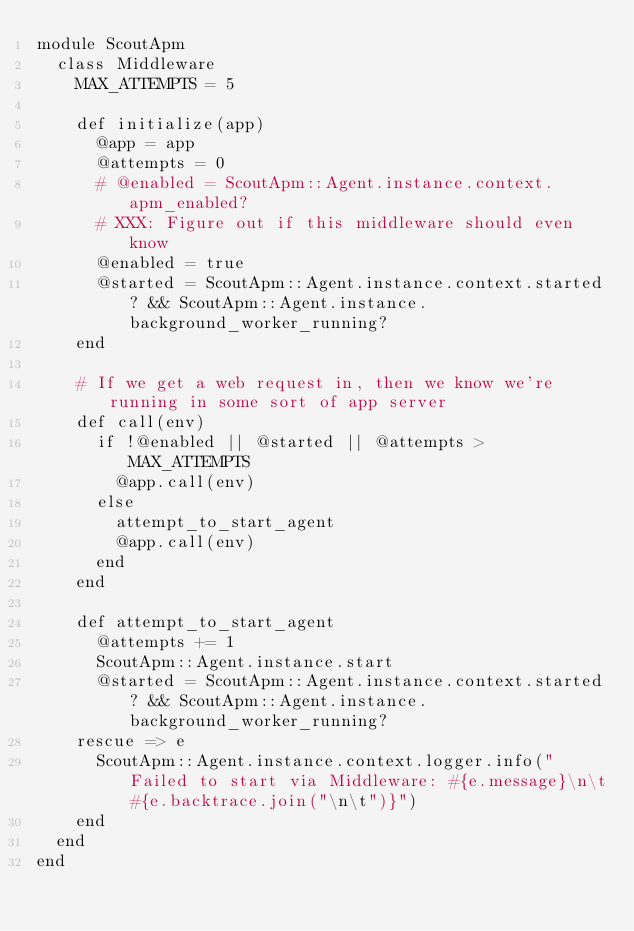<code> <loc_0><loc_0><loc_500><loc_500><_Ruby_>module ScoutApm
  class Middleware
    MAX_ATTEMPTS = 5

    def initialize(app)
      @app = app
      @attempts = 0
      # @enabled = ScoutApm::Agent.instance.context.apm_enabled?
      # XXX: Figure out if this middleware should even know
      @enabled = true
      @started = ScoutApm::Agent.instance.context.started? && ScoutApm::Agent.instance.background_worker_running?
    end

    # If we get a web request in, then we know we're running in some sort of app server
    def call(env)
      if !@enabled || @started || @attempts > MAX_ATTEMPTS
        @app.call(env)
      else
        attempt_to_start_agent
        @app.call(env)
      end
    end

    def attempt_to_start_agent
      @attempts += 1
      ScoutApm::Agent.instance.start
      @started = ScoutApm::Agent.instance.context.started? && ScoutApm::Agent.instance.background_worker_running?
    rescue => e
      ScoutApm::Agent.instance.context.logger.info("Failed to start via Middleware: #{e.message}\n\t#{e.backtrace.join("\n\t")}")
    end
  end
end
</code> 